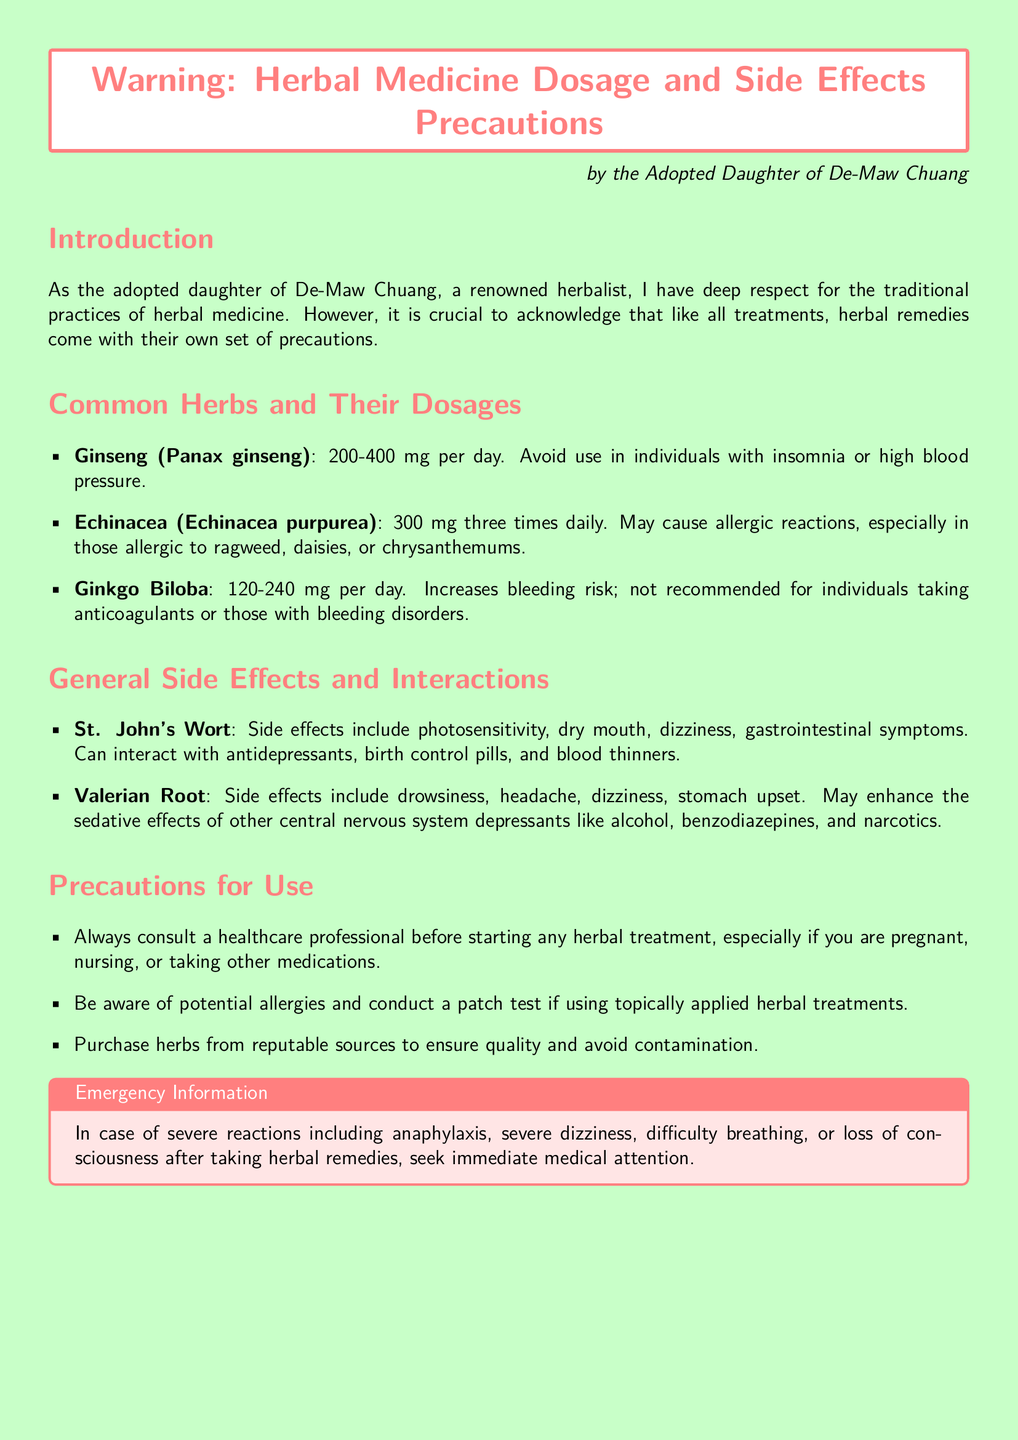What is the recommended daily dosage of Ginseng? The document specifies that the daily dosage of Ginseng is 200-400 mg.
Answer: 200-400 mg What are common side effects of Valerian Root? The document lists drowsiness, headache, dizziness, and stomach upset as side effects of Valerian Root.
Answer: Drowsiness, headache, dizziness, stomach upset Which herb may cause allergic reactions in individuals allergic to ragweed? According to the document, Echinacea may cause allergic reactions in those allergic to ragweed.
Answer: Echinacea What interactions should be considered for St. John's Wort? St. John's Wort can interact with antidepressants, birth control pills, and blood thinners.
Answer: Antidepressants, birth control pills, blood thinners What should you do in case of severe reactions after taking herbal remedies? The document advises seeking immediate medical attention in case of severe reactions.
Answer: Seek immediate medical attention Who should you consult before starting any herbal treatment? The document states you should consult a healthcare professional before starting any herbal treatment.
Answer: Healthcare professional What is the purpose of purchasing herbs from reputable sources? The purpose is to ensure quality and avoid contamination according to the document.
Answer: Ensure quality and avoid contamination What is the side effect that Ginkgo Biloba increases the risk of? The document mentions Ginkgo Biloba increases the bleeding risk.
Answer: Bleeding risk 